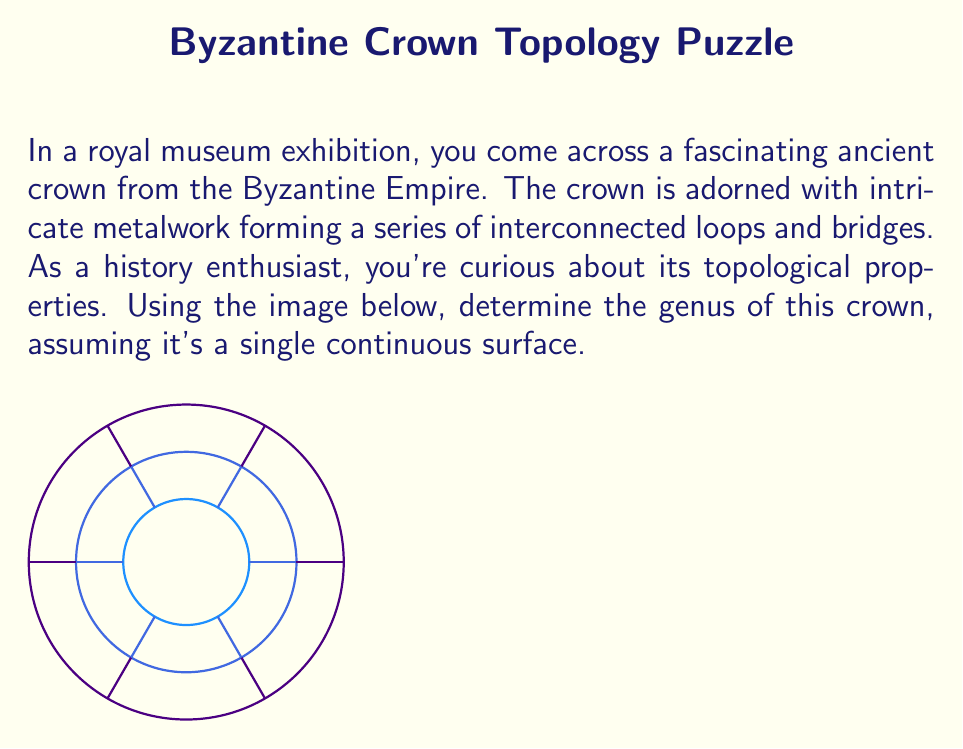Provide a solution to this math problem. To determine the genus of the crown, we need to follow these steps:

1) First, recall that the genus of a surface is the maximum number of cuts along non-intersecting closed simple curves without rendering the surface disconnected.

2) In this crown, we can identify three main circular components connected by six radial bridges.

3) Let's count the number of holes:
   - There are 2 large holes between the outer and middle circles
   - There are 2 small holes between the middle and inner circles
   - Total number of holes = 2 + 2 = 4

4) In topology, the relationship between genus ($g$) and the number of holes ($h$) for a connected surface is given by:

   $$g = \frac{h}{2}$$

5) Substituting our value:

   $$g = \frac{4}{2} = 2$$

Therefore, the genus of this Byzantine crown is 2.
Answer: $2$ 